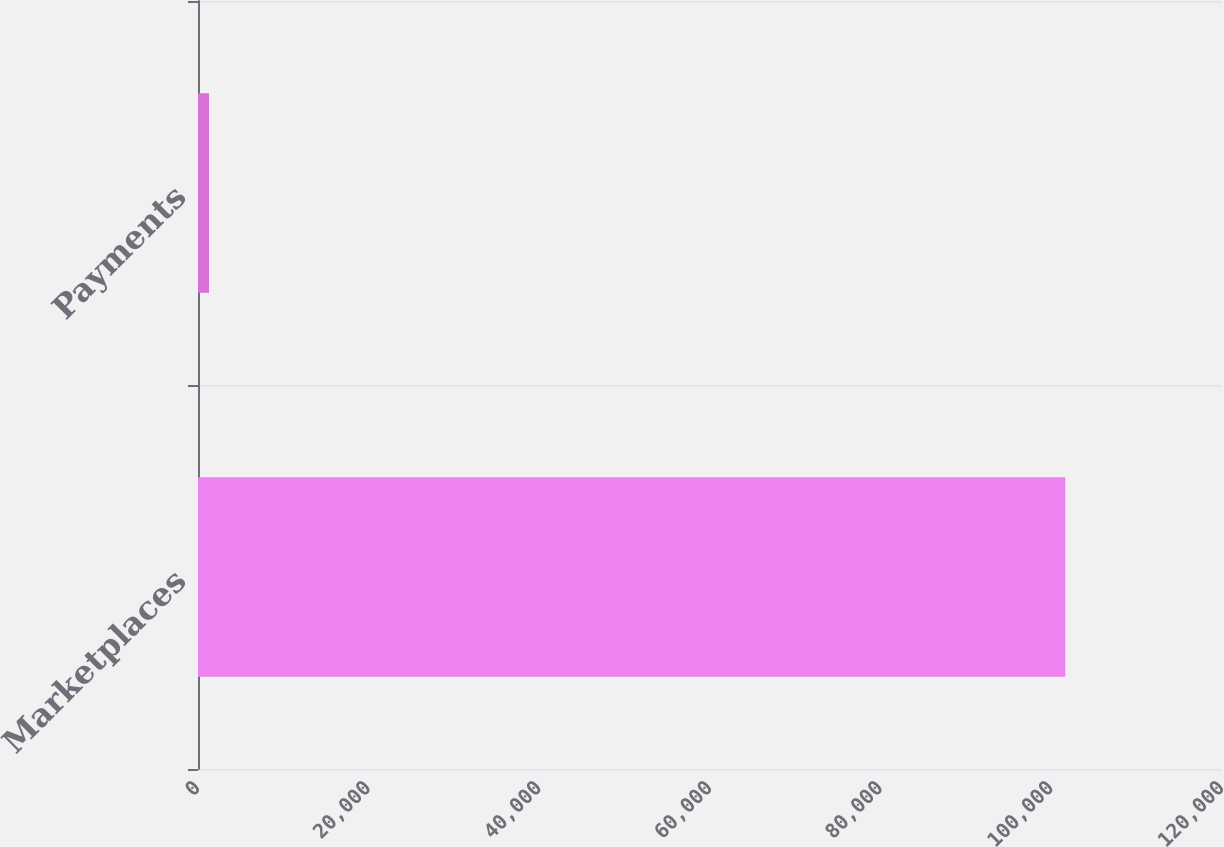<chart> <loc_0><loc_0><loc_500><loc_500><bar_chart><fcel>Marketplaces<fcel>Payments<nl><fcel>101632<fcel>1290<nl></chart> 